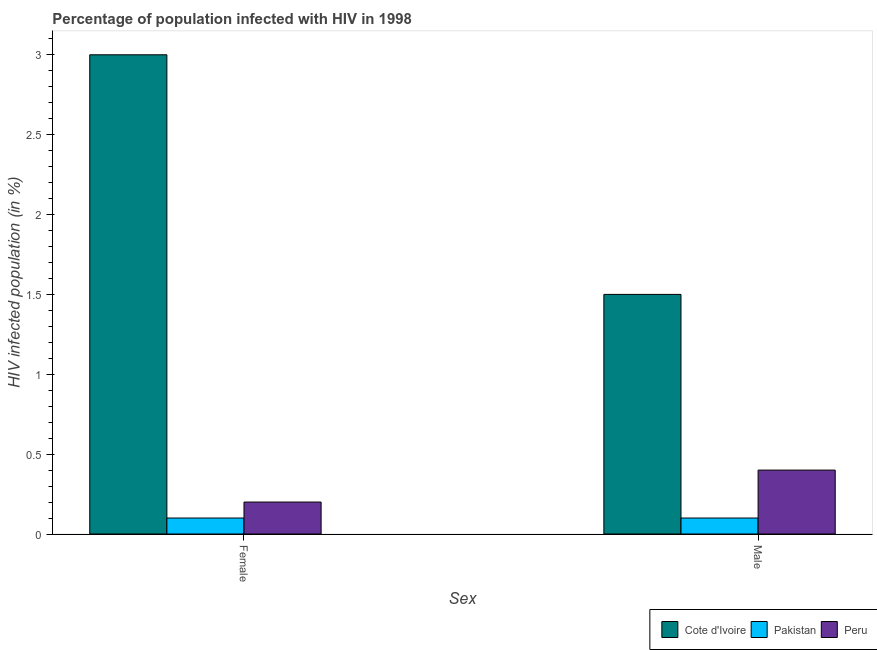How many different coloured bars are there?
Provide a short and direct response. 3. Are the number of bars per tick equal to the number of legend labels?
Provide a succinct answer. Yes. How many bars are there on the 2nd tick from the right?
Ensure brevity in your answer.  3. Across all countries, what is the maximum percentage of males who are infected with hiv?
Your answer should be very brief. 1.5. In which country was the percentage of females who are infected with hiv maximum?
Ensure brevity in your answer.  Cote d'Ivoire. In which country was the percentage of males who are infected with hiv minimum?
Ensure brevity in your answer.  Pakistan. What is the difference between the percentage of females who are infected with hiv in Pakistan and that in Peru?
Provide a succinct answer. -0.1. What is the difference between the percentage of females who are infected with hiv in Pakistan and the percentage of males who are infected with hiv in Peru?
Your answer should be very brief. -0.3. In how many countries, is the percentage of females who are infected with hiv greater than 2.8 %?
Offer a very short reply. 1. What is the ratio of the percentage of males who are infected with hiv in Pakistan to that in Cote d'Ivoire?
Ensure brevity in your answer.  0.07. Is the percentage of females who are infected with hiv in Cote d'Ivoire less than that in Pakistan?
Keep it short and to the point. No. What is the difference between two consecutive major ticks on the Y-axis?
Your answer should be compact. 0.5. Does the graph contain any zero values?
Give a very brief answer. No. Where does the legend appear in the graph?
Offer a very short reply. Bottom right. How many legend labels are there?
Provide a short and direct response. 3. What is the title of the graph?
Your response must be concise. Percentage of population infected with HIV in 1998. What is the label or title of the X-axis?
Give a very brief answer. Sex. What is the label or title of the Y-axis?
Ensure brevity in your answer.  HIV infected population (in %). What is the HIV infected population (in %) of Pakistan in Female?
Your answer should be compact. 0.1. What is the HIV infected population (in %) of Peru in Female?
Your response must be concise. 0.2. What is the HIV infected population (in %) of Cote d'Ivoire in Male?
Provide a succinct answer. 1.5. What is the HIV infected population (in %) in Pakistan in Male?
Offer a terse response. 0.1. What is the HIV infected population (in %) in Peru in Male?
Keep it short and to the point. 0.4. Across all Sex, what is the maximum HIV infected population (in %) of Cote d'Ivoire?
Offer a terse response. 3. Across all Sex, what is the maximum HIV infected population (in %) in Pakistan?
Your answer should be compact. 0.1. Across all Sex, what is the minimum HIV infected population (in %) of Cote d'Ivoire?
Your answer should be compact. 1.5. Across all Sex, what is the minimum HIV infected population (in %) in Pakistan?
Your answer should be compact. 0.1. Across all Sex, what is the minimum HIV infected population (in %) of Peru?
Provide a short and direct response. 0.2. What is the total HIV infected population (in %) of Pakistan in the graph?
Ensure brevity in your answer.  0.2. What is the total HIV infected population (in %) of Peru in the graph?
Make the answer very short. 0.6. What is the difference between the HIV infected population (in %) of Pakistan in Female and that in Male?
Your answer should be compact. 0. What is the difference between the HIV infected population (in %) in Peru in Female and that in Male?
Your response must be concise. -0.2. What is the difference between the HIV infected population (in %) in Cote d'Ivoire in Female and the HIV infected population (in %) in Peru in Male?
Offer a very short reply. 2.6. What is the average HIV infected population (in %) in Cote d'Ivoire per Sex?
Give a very brief answer. 2.25. What is the average HIV infected population (in %) in Pakistan per Sex?
Offer a very short reply. 0.1. What is the average HIV infected population (in %) of Peru per Sex?
Your answer should be compact. 0.3. What is the difference between the HIV infected population (in %) of Cote d'Ivoire and HIV infected population (in %) of Pakistan in Female?
Make the answer very short. 2.9. What is the difference between the HIV infected population (in %) in Cote d'Ivoire and HIV infected population (in %) in Peru in Male?
Offer a terse response. 1.1. What is the ratio of the HIV infected population (in %) of Cote d'Ivoire in Female to that in Male?
Keep it short and to the point. 2. What is the ratio of the HIV infected population (in %) of Pakistan in Female to that in Male?
Provide a succinct answer. 1. What is the difference between the highest and the second highest HIV infected population (in %) in Cote d'Ivoire?
Ensure brevity in your answer.  1.5. What is the difference between the highest and the second highest HIV infected population (in %) of Pakistan?
Your answer should be very brief. 0. What is the difference between the highest and the lowest HIV infected population (in %) in Pakistan?
Ensure brevity in your answer.  0. 